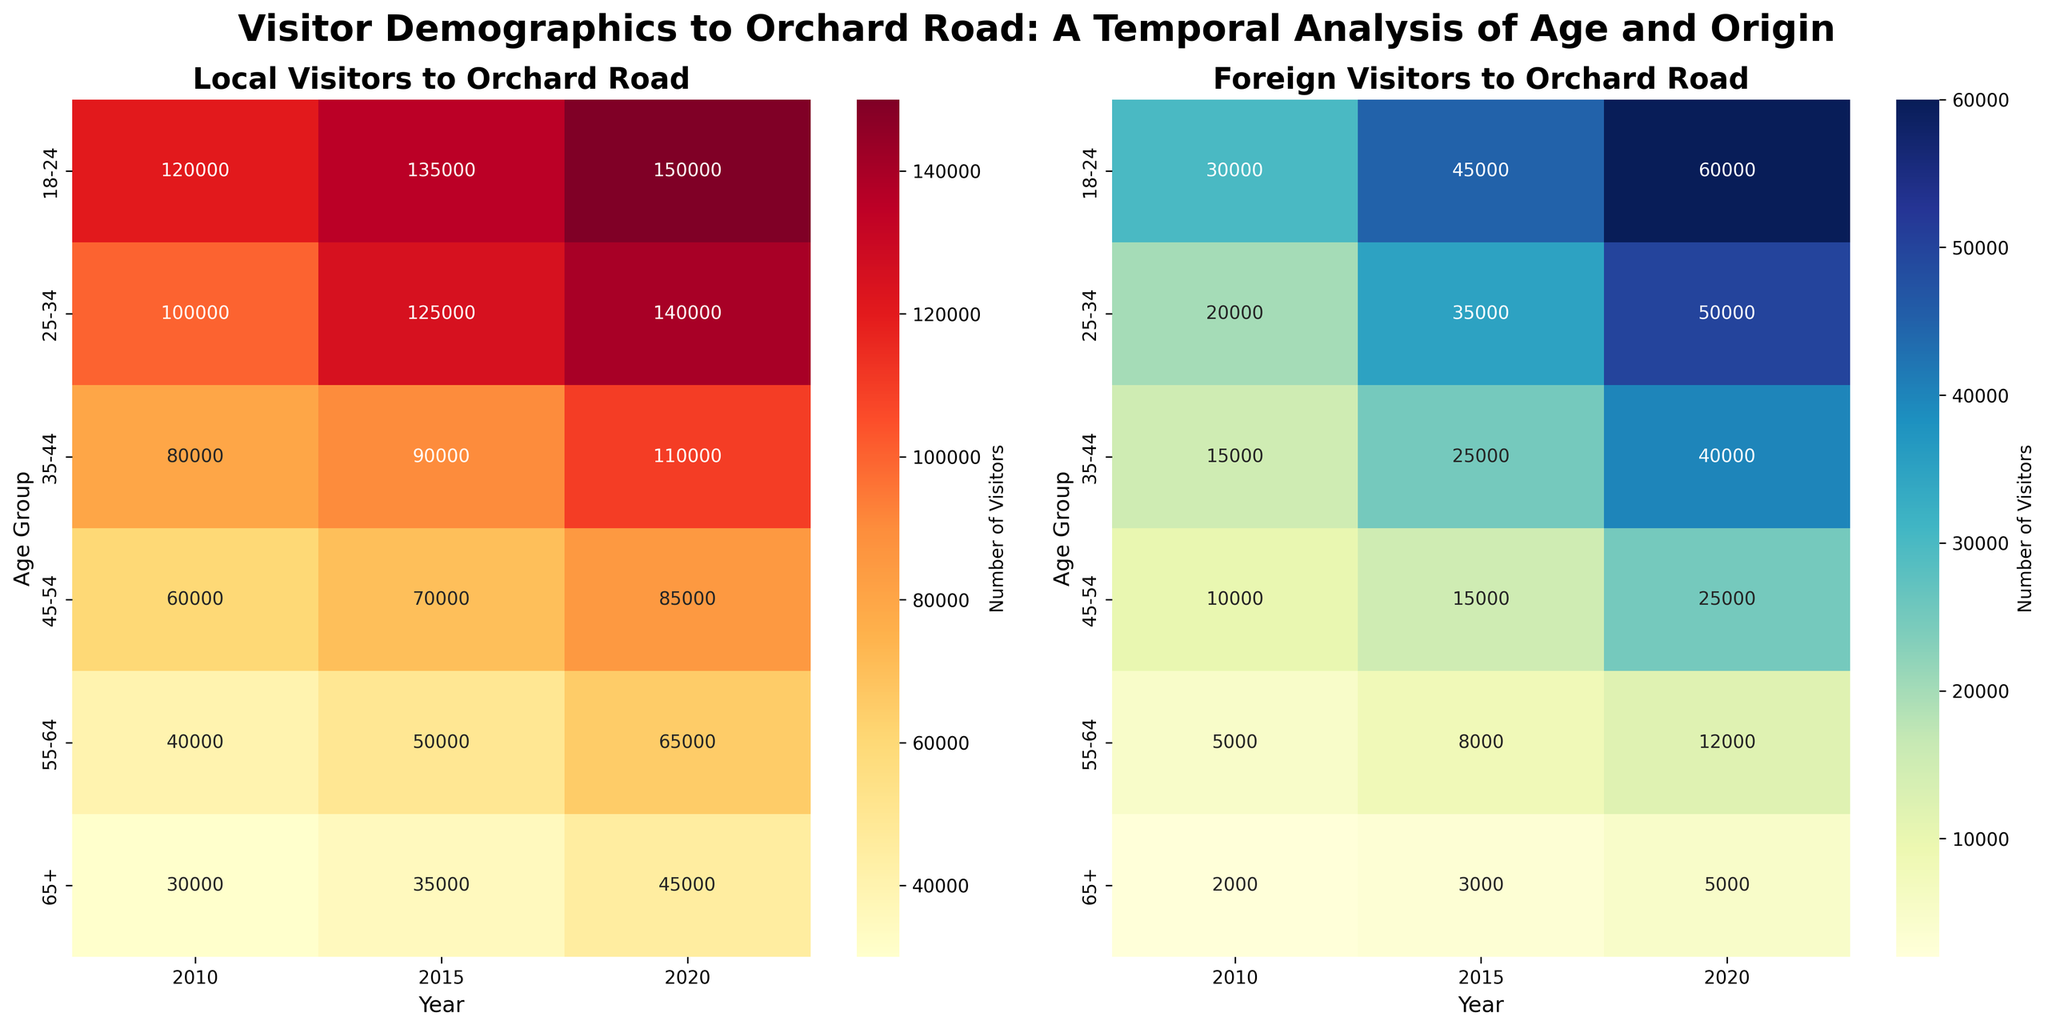What's the title of the left heatmap? Look at the text above the left heatmap. The title is directly above the heatmap.
Answer: Local Visitors to Orchard Road How many years of data are shown on the heatmaps? Count the number of different years along the x-axis of either heatmap.
Answer: 3 Which age group had the highest number of local visitors in 2020? Find the age group row in the left heatmap corresponding to the year 2020 and look for the highest value.
Answer: 18-24 What is the difference in the number of foreign visitors between the 55-64 and 65+ age groups in 2015? Find the values for both age groups in the 2015 column on the right heatmap and subtract the smaller value from the larger one.
Answer: 5000 Which age group saw the largest increase in local visitors from 2010 to 2020? For each age group in the left heatmap, subtract the number of visitors in 2010 from the number in 2020, and identify which age group has the largest difference.
Answer: 18-24 How many more foreign visitors were there in the 45-54 age group in 2020 compared to 2015? Locate the values for the 45-54 age group for both years on the right heatmap and subtract the 2015 value from the 2020 value.
Answer: 10000 What is the total number of foreign visitors for the age group 25-34 across all years? Summing the 25-34 values in the right heatmap across the years 2010, 2015, and 2020.
Answer: 105000 Which age group had the smallest number of foreign visitors in 2010? Identify the smallest value in the 2010 column on the right heatmap and note the corresponding age group.
Answer: 65+ What is the average number of local visitors for the 35-44 age group over the three years? Add together the values for the 35-44 age group in the left heatmap for 2010, 2015, and 2020, and then divide by 3.
Answer: 93333 Which year had the highest number of foreign visitors for the age group 18-24? Compare the numbers for the 18-24 age group in the right heatmap across the three years and identify the year with the highest value.
Answer: 2020 